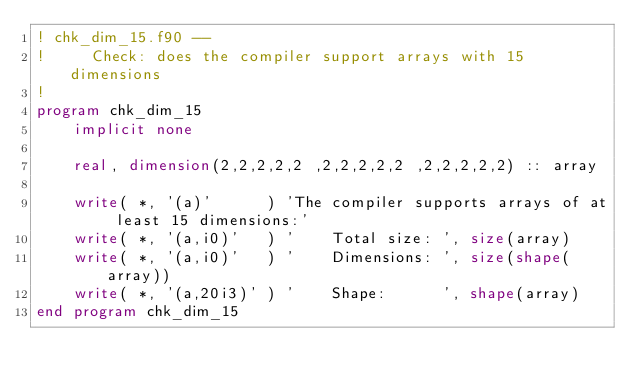Convert code to text. <code><loc_0><loc_0><loc_500><loc_500><_FORTRAN_>! chk_dim_15.f90 --
!     Check: does the compiler support arrays with 15 dimensions
!
program chk_dim_15
    implicit none

    real, dimension(2,2,2,2,2 ,2,2,2,2,2 ,2,2,2,2,2) :: array

    write( *, '(a)'      ) 'The compiler supports arrays of at least 15 dimensions:'
    write( *, '(a,i0)'   ) '    Total size: ', size(array)
    write( *, '(a,i0)'   ) '    Dimensions: ', size(shape(array))
    write( *, '(a,20i3)' ) '    Shape:      ', shape(array)
end program chk_dim_15
</code> 